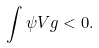Convert formula to latex. <formula><loc_0><loc_0><loc_500><loc_500>\int \psi V g < 0 .</formula> 